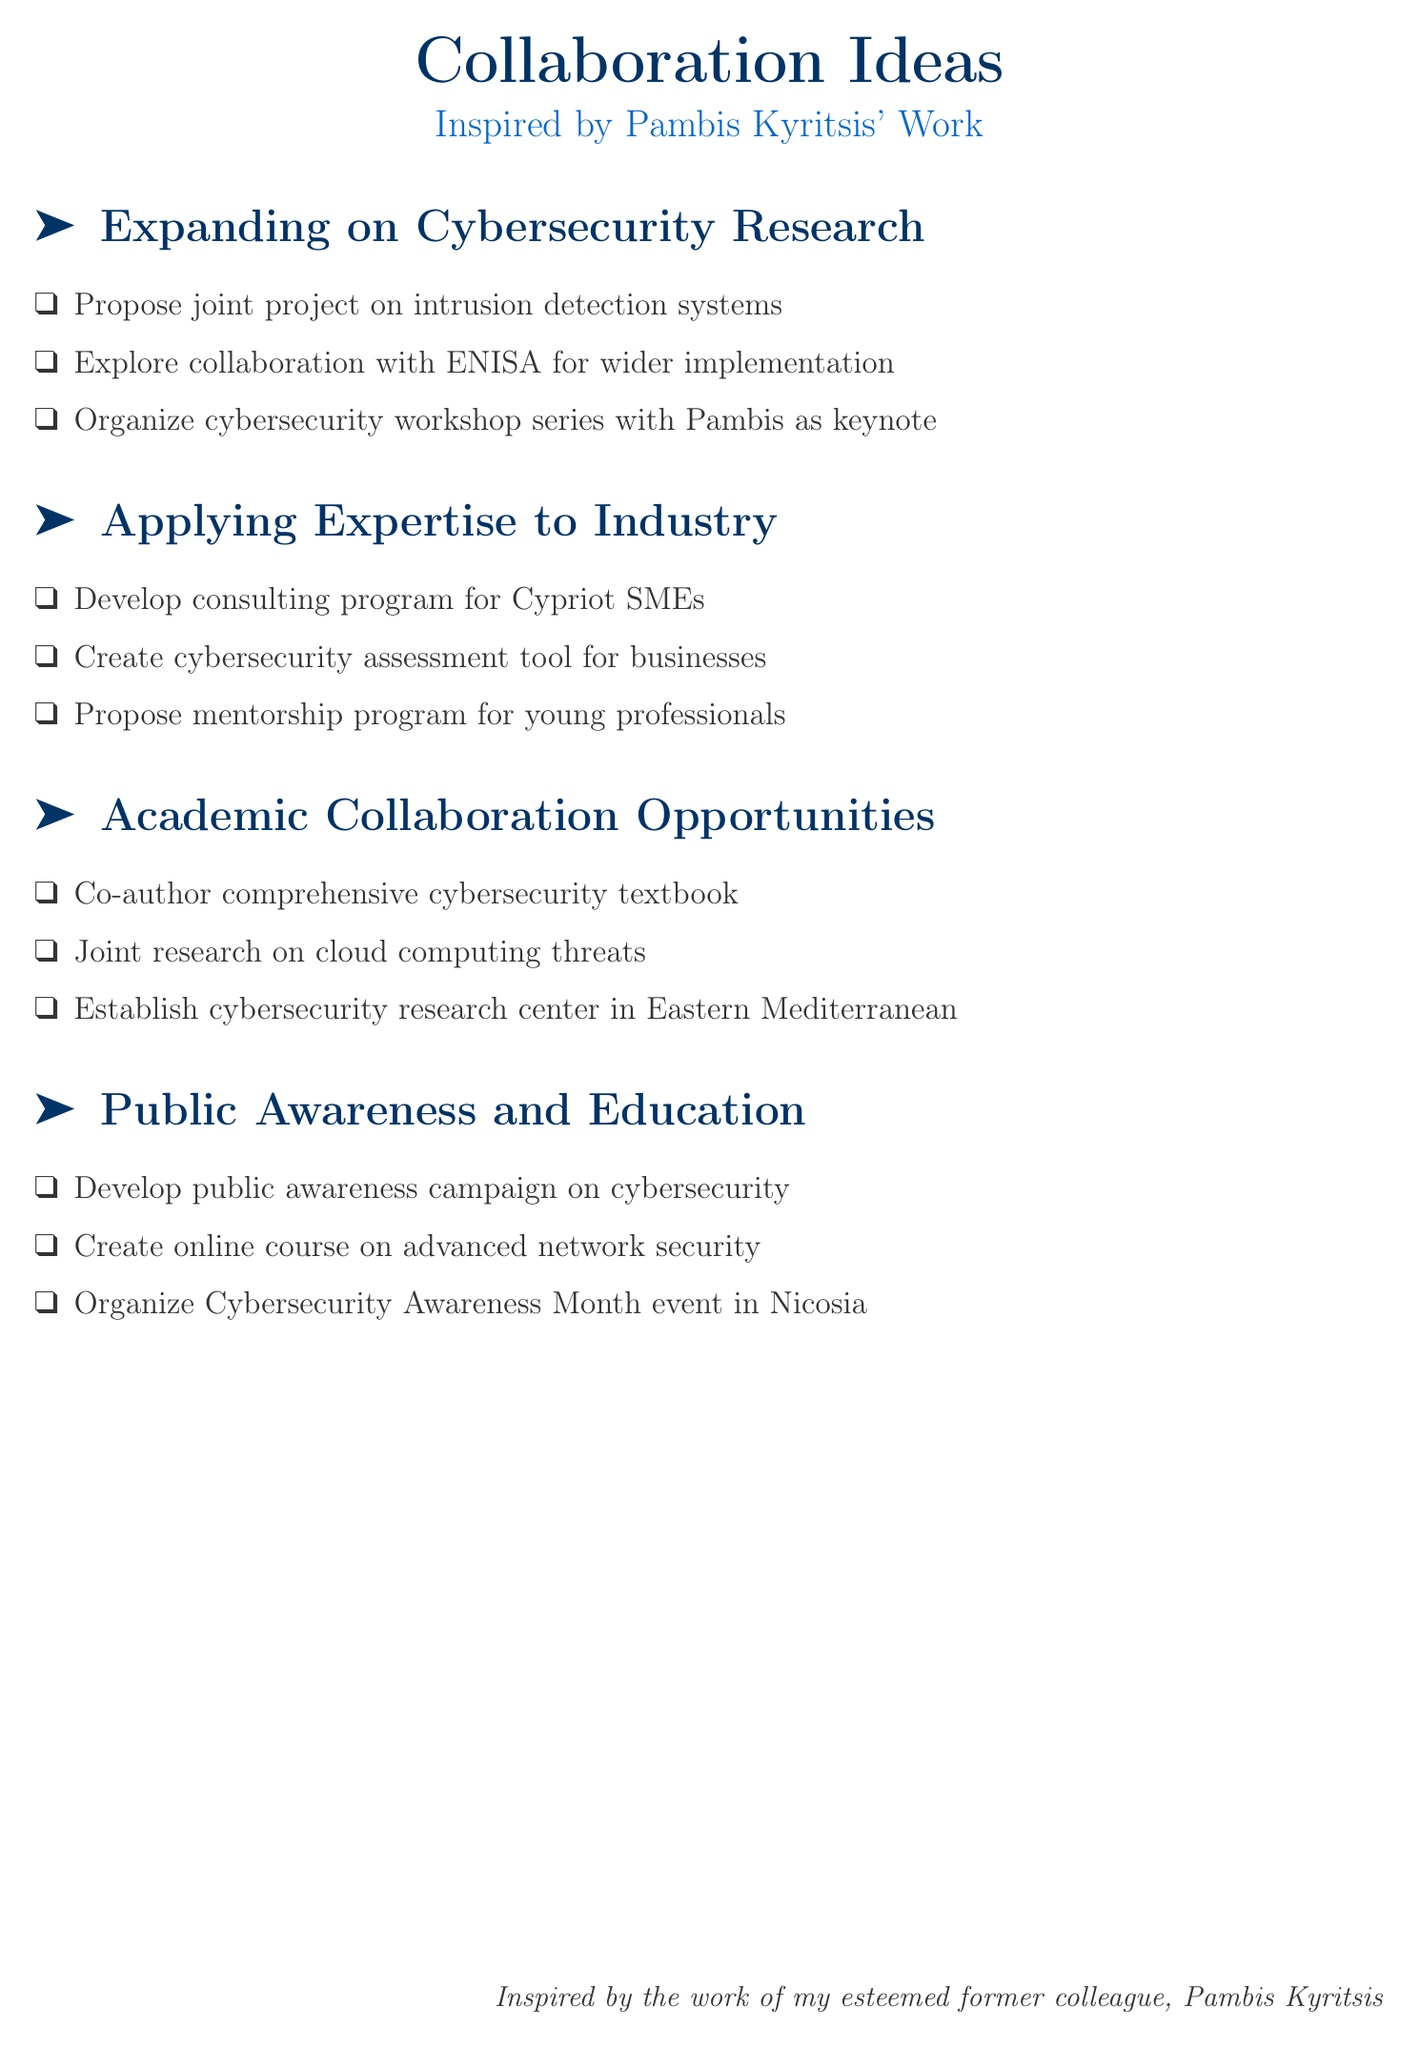What is the first proposed project topic? The first proposed project topic is enhancing intrusion detection systems.
Answer: enhancing intrusion detection systems Which organization is suggested for collaboration in implementing findings? The European Union Agency for Cybersecurity (ENISA) is suggested for collaboration.
Answer: ENISA What educational initiative is proposed for Nicosia? A Cybersecurity Awareness Month event is proposed.
Answer: Cybersecurity Awareness Month event How many points are listed under "Applying Pambis Kyritsis' Expertise to Industry Challenges"? There are three points listed under that section.
Answer: three What type of course is proposed to be created with Pambis as instructor? An online course on advanced network security techniques is proposed.
Answer: online course on advanced network security techniques What is the main focus of the joint research project proposed with the University of Cyprus? The main focus is on emerging threats in cloud computing.
Answer: emerging threats in cloud computing What is the suggested outcome of establishing a mentorship program? The outcome is to guide young professionals in the field of information security.
Answer: guide young professionals What type of textbook is suggested to co-author with Pambis? A comprehensive cybersecurity textbook is suggested.
Answer: comprehensive cybersecurity textbook 